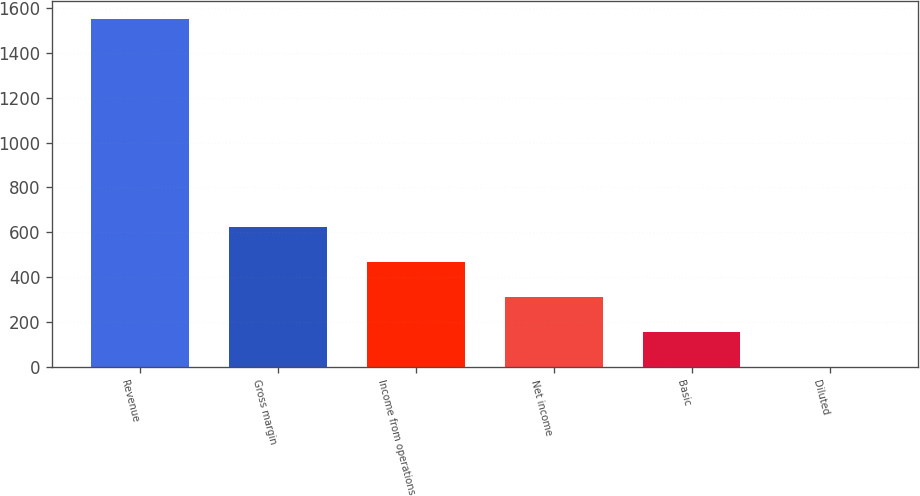Convert chart to OTSL. <chart><loc_0><loc_0><loc_500><loc_500><bar_chart><fcel>Revenue<fcel>Gross margin<fcel>Income from operations<fcel>Net income<fcel>Basic<fcel>Diluted<nl><fcel>1553<fcel>621.41<fcel>466.14<fcel>310.87<fcel>155.6<fcel>0.33<nl></chart> 